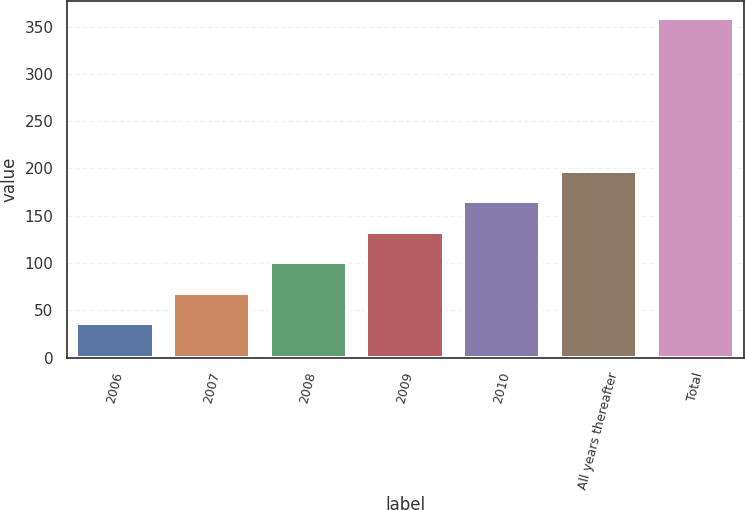Convert chart to OTSL. <chart><loc_0><loc_0><loc_500><loc_500><bar_chart><fcel>2006<fcel>2007<fcel>2008<fcel>2009<fcel>2010<fcel>All years thereafter<fcel>Total<nl><fcel>36<fcel>68.3<fcel>100.6<fcel>132.9<fcel>165.2<fcel>197.5<fcel>359<nl></chart> 